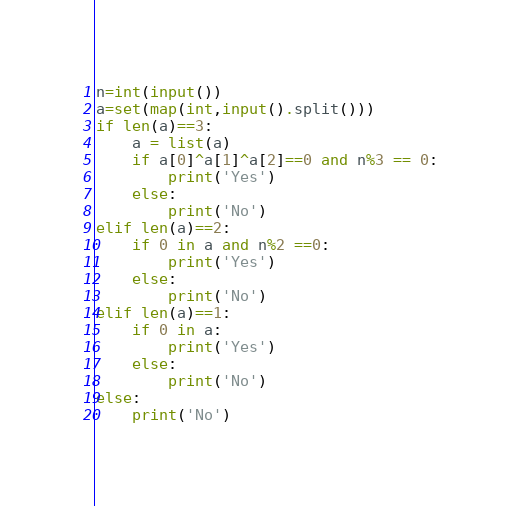Convert code to text. <code><loc_0><loc_0><loc_500><loc_500><_Python_>n=int(input())
a=set(map(int,input().split()))
if len(a)==3:
    a = list(a)
    if a[0]^a[1]^a[2]==0 and n%3 == 0:
        print('Yes')
    else:
        print('No')
elif len(a)==2:
    if 0 in a and n%2 ==0:
        print('Yes')
    else:
        print('No')
elif len(a)==1:
    if 0 in a:
        print('Yes')
    else:
        print('No')
else:
    print('No')</code> 